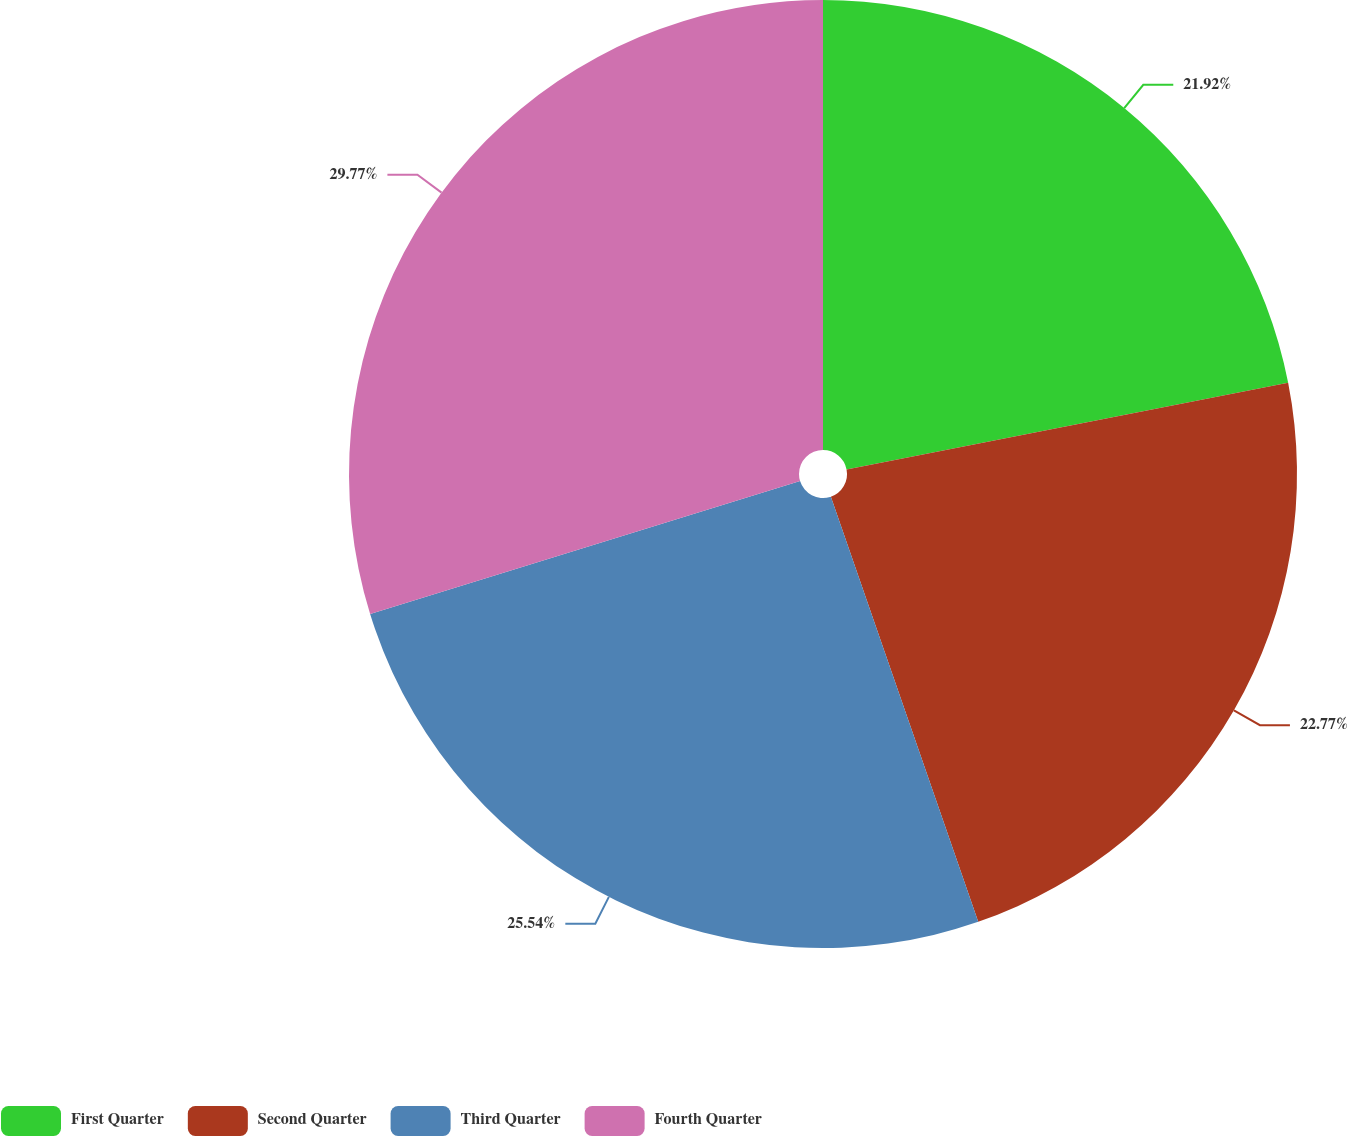<chart> <loc_0><loc_0><loc_500><loc_500><pie_chart><fcel>First Quarter<fcel>Second Quarter<fcel>Third Quarter<fcel>Fourth Quarter<nl><fcel>21.92%<fcel>22.77%<fcel>25.54%<fcel>29.77%<nl></chart> 